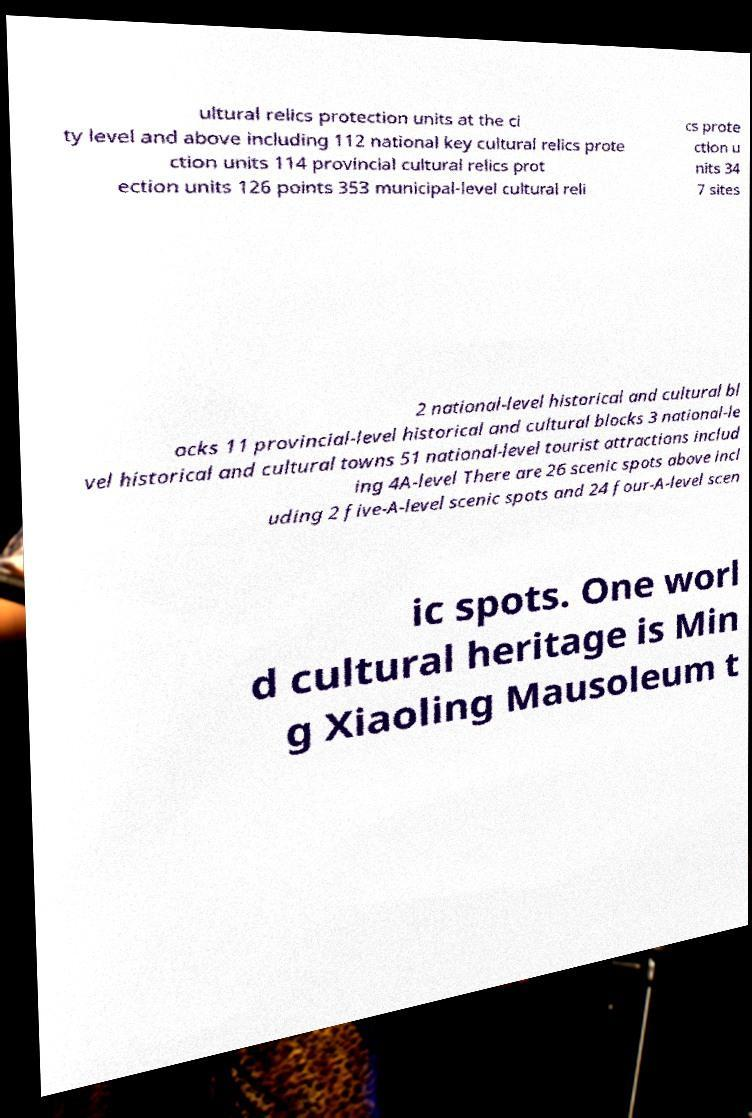Could you assist in decoding the text presented in this image and type it out clearly? ultural relics protection units at the ci ty level and above including 112 national key cultural relics prote ction units 114 provincial cultural relics prot ection units 126 points 353 municipal-level cultural reli cs prote ction u nits 34 7 sites 2 national-level historical and cultural bl ocks 11 provincial-level historical and cultural blocks 3 national-le vel historical and cultural towns 51 national-level tourist attractions includ ing 4A-level There are 26 scenic spots above incl uding 2 five-A-level scenic spots and 24 four-A-level scen ic spots. One worl d cultural heritage is Min g Xiaoling Mausoleum t 